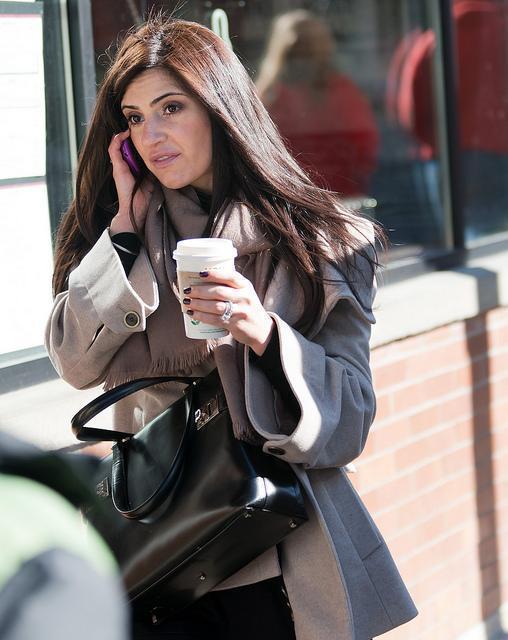What pick me up is found in this woman's cup?
From the following four choices, select the correct answer to address the question.
Options: Soy milk, foam, caffeine, milk. Caffeine. 